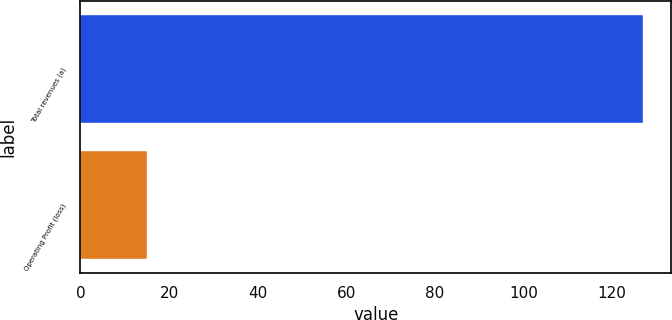Convert chart to OTSL. <chart><loc_0><loc_0><loc_500><loc_500><bar_chart><fcel>Total revenues (a)<fcel>Operating Profit (loss)<nl><fcel>127<fcel>15<nl></chart> 